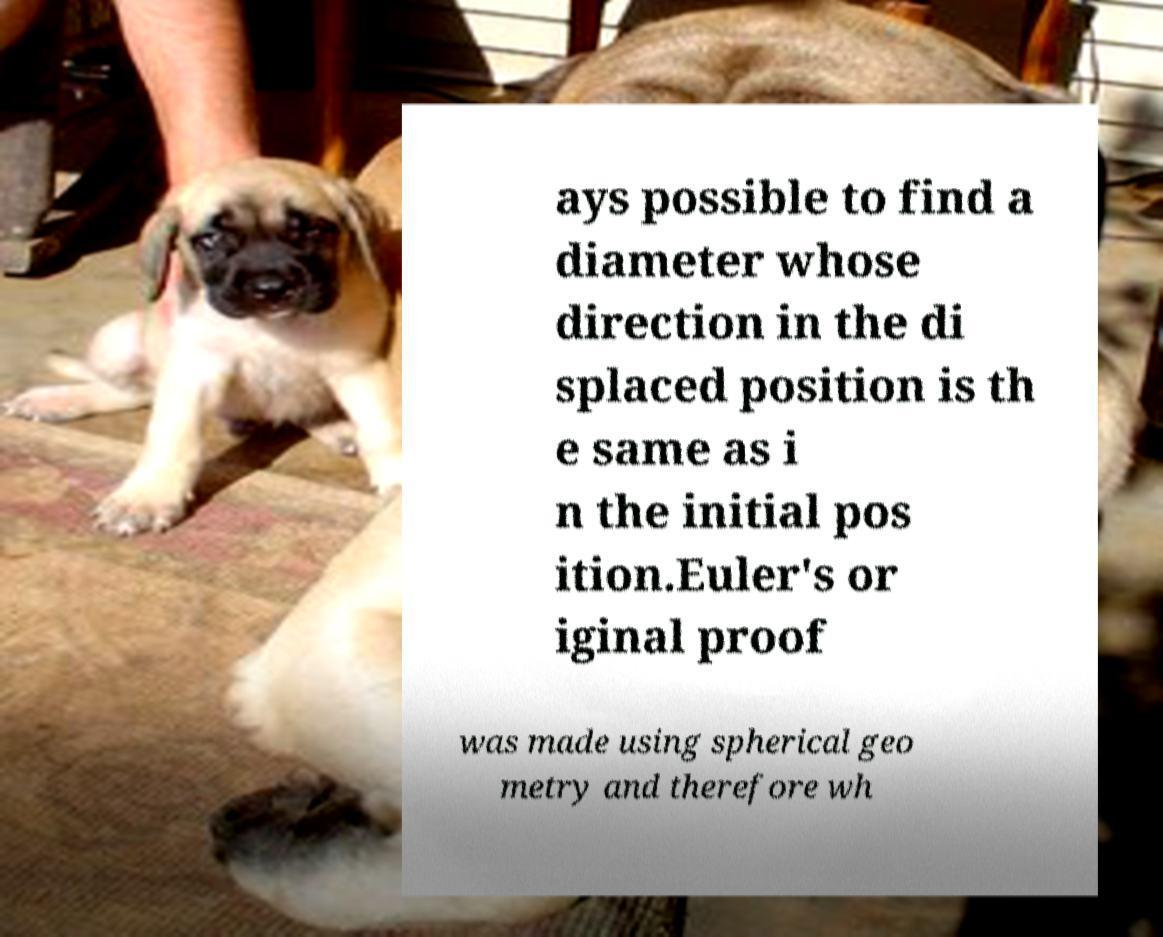Can you accurately transcribe the text from the provided image for me? ays possible to find a diameter whose direction in the di splaced position is th e same as i n the initial pos ition.Euler's or iginal proof was made using spherical geo metry and therefore wh 